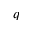<formula> <loc_0><loc_0><loc_500><loc_500>q</formula> 